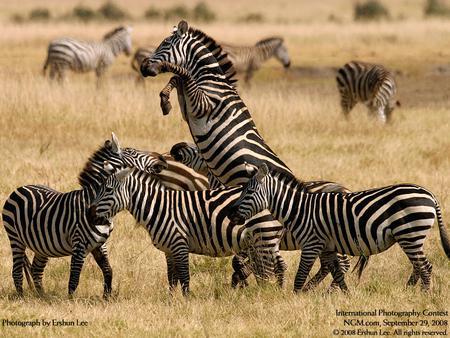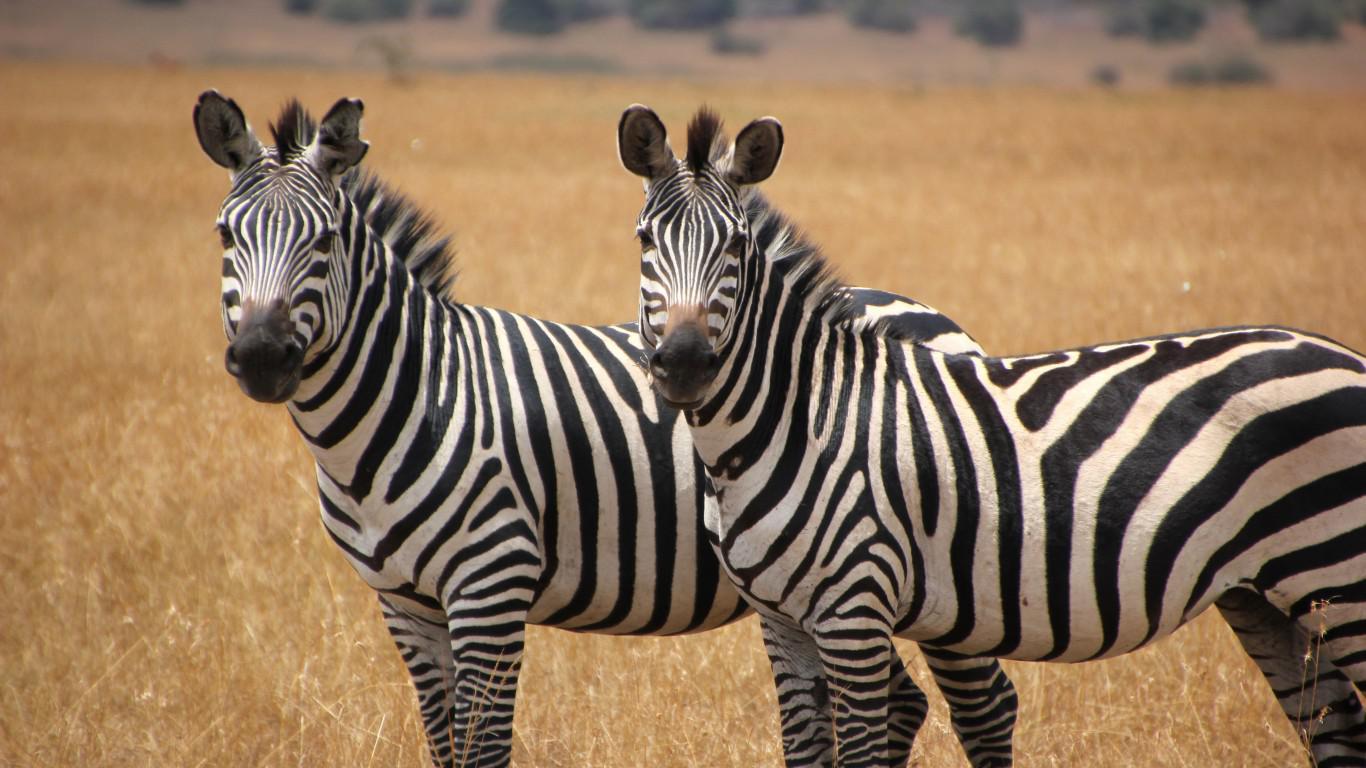The first image is the image on the left, the second image is the image on the right. Analyze the images presented: Is the assertion "One image shows a herd of zebras in profile all moving toward the right and stirring up the non-grass material under their feet." valid? Answer yes or no. No. The first image is the image on the left, the second image is the image on the right. Evaluate the accuracy of this statement regarding the images: "One animal in one of the images is bucking.". Is it true? Answer yes or no. Yes. 